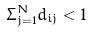<formula> <loc_0><loc_0><loc_500><loc_500>\Sigma _ { j = 1 } ^ { N } d _ { i j } < 1</formula> 